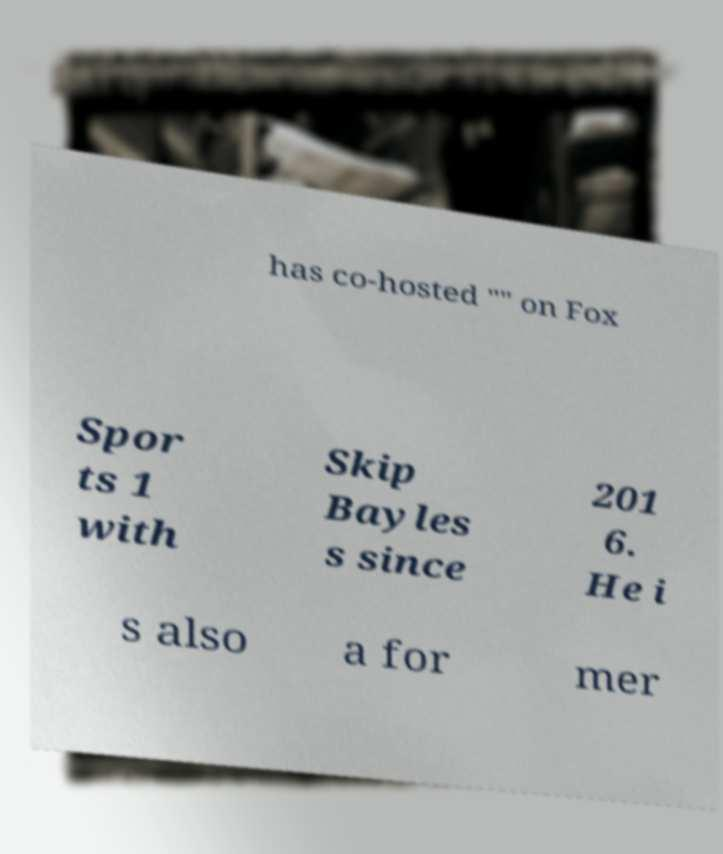Can you accurately transcribe the text from the provided image for me? has co-hosted "" on Fox Spor ts 1 with Skip Bayles s since 201 6. He i s also a for mer 